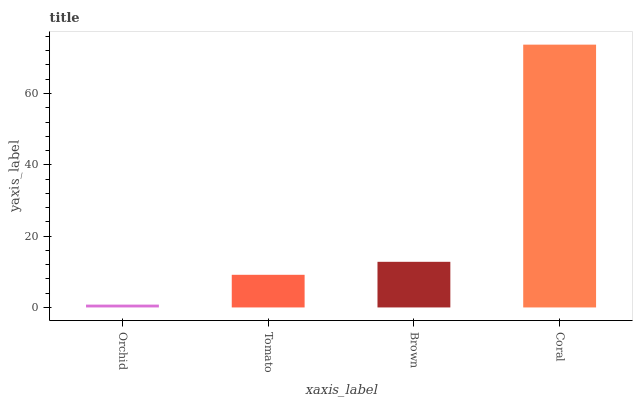Is Orchid the minimum?
Answer yes or no. Yes. Is Coral the maximum?
Answer yes or no. Yes. Is Tomato the minimum?
Answer yes or no. No. Is Tomato the maximum?
Answer yes or no. No. Is Tomato greater than Orchid?
Answer yes or no. Yes. Is Orchid less than Tomato?
Answer yes or no. Yes. Is Orchid greater than Tomato?
Answer yes or no. No. Is Tomato less than Orchid?
Answer yes or no. No. Is Brown the high median?
Answer yes or no. Yes. Is Tomato the low median?
Answer yes or no. Yes. Is Tomato the high median?
Answer yes or no. No. Is Brown the low median?
Answer yes or no. No. 